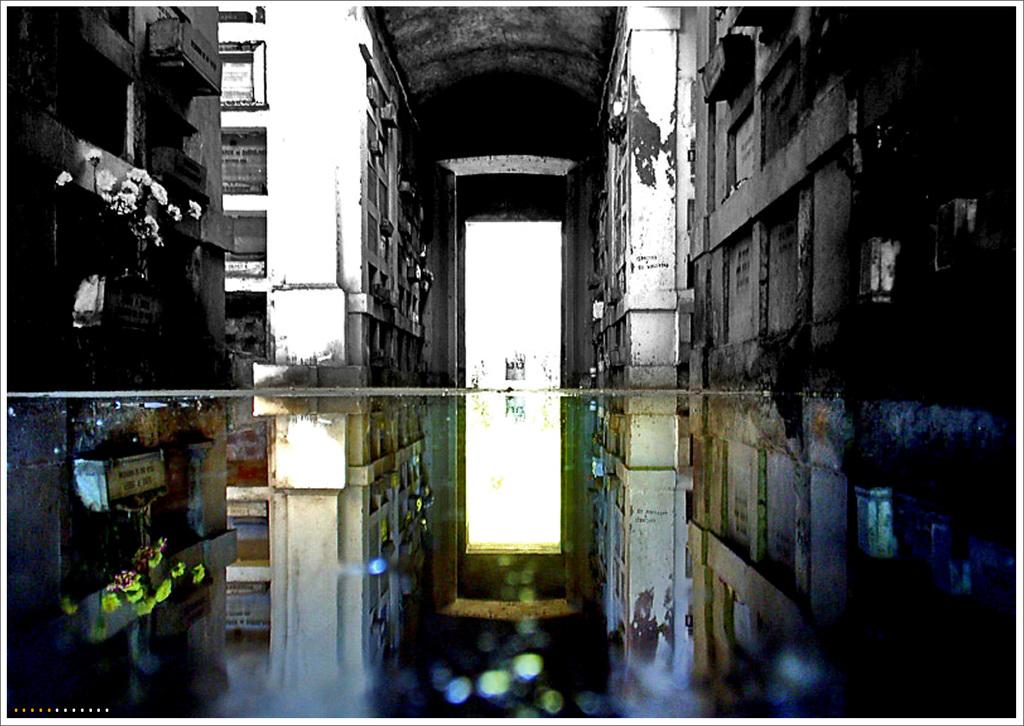What is present in the image that is not solid? Water is visible in the image, which is not solid. What type of structures can be seen in the image? There are buildings with windows in the image. What type of plants are present in the image? There are flowers in the image. What architectural feature can be seen in the image? There is an arch in the image. What other unspecified items are present in the image? There are some unspecified objects in the image. What type of plastic is used to make the lunch in the image? There is no lunch present in the image, so it is not possible to determine what type of plastic might be used. 